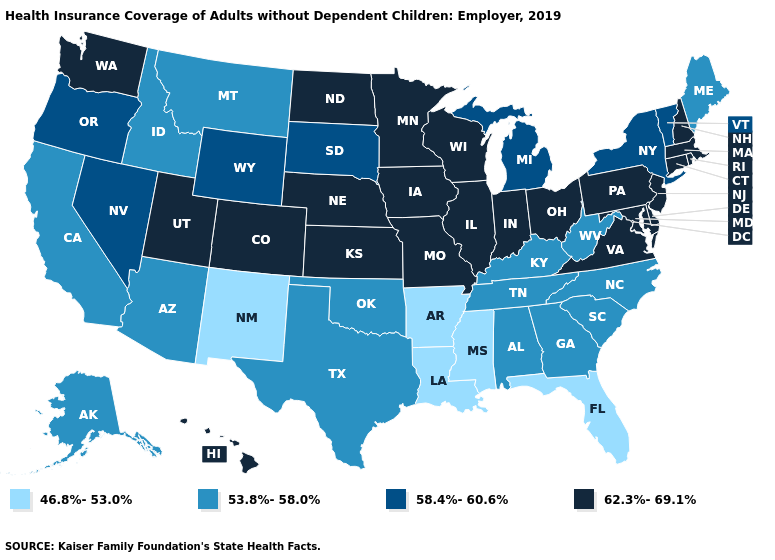Does Illinois have the same value as Ohio?
Concise answer only. Yes. Name the states that have a value in the range 62.3%-69.1%?
Give a very brief answer. Colorado, Connecticut, Delaware, Hawaii, Illinois, Indiana, Iowa, Kansas, Maryland, Massachusetts, Minnesota, Missouri, Nebraska, New Hampshire, New Jersey, North Dakota, Ohio, Pennsylvania, Rhode Island, Utah, Virginia, Washington, Wisconsin. Does Nevada have the highest value in the West?
Write a very short answer. No. What is the value of Washington?
Keep it brief. 62.3%-69.1%. Name the states that have a value in the range 53.8%-58.0%?
Be succinct. Alabama, Alaska, Arizona, California, Georgia, Idaho, Kentucky, Maine, Montana, North Carolina, Oklahoma, South Carolina, Tennessee, Texas, West Virginia. What is the highest value in the West ?
Give a very brief answer. 62.3%-69.1%. What is the lowest value in the West?
Give a very brief answer. 46.8%-53.0%. Name the states that have a value in the range 53.8%-58.0%?
Quick response, please. Alabama, Alaska, Arizona, California, Georgia, Idaho, Kentucky, Maine, Montana, North Carolina, Oklahoma, South Carolina, Tennessee, Texas, West Virginia. What is the value of California?
Quick response, please. 53.8%-58.0%. Which states have the highest value in the USA?
Concise answer only. Colorado, Connecticut, Delaware, Hawaii, Illinois, Indiana, Iowa, Kansas, Maryland, Massachusetts, Minnesota, Missouri, Nebraska, New Hampshire, New Jersey, North Dakota, Ohio, Pennsylvania, Rhode Island, Utah, Virginia, Washington, Wisconsin. What is the highest value in states that border Michigan?
Write a very short answer. 62.3%-69.1%. Name the states that have a value in the range 62.3%-69.1%?
Be succinct. Colorado, Connecticut, Delaware, Hawaii, Illinois, Indiana, Iowa, Kansas, Maryland, Massachusetts, Minnesota, Missouri, Nebraska, New Hampshire, New Jersey, North Dakota, Ohio, Pennsylvania, Rhode Island, Utah, Virginia, Washington, Wisconsin. Name the states that have a value in the range 46.8%-53.0%?
Keep it brief. Arkansas, Florida, Louisiana, Mississippi, New Mexico. Which states hav the highest value in the West?
Be succinct. Colorado, Hawaii, Utah, Washington. What is the value of Washington?
Be succinct. 62.3%-69.1%. 